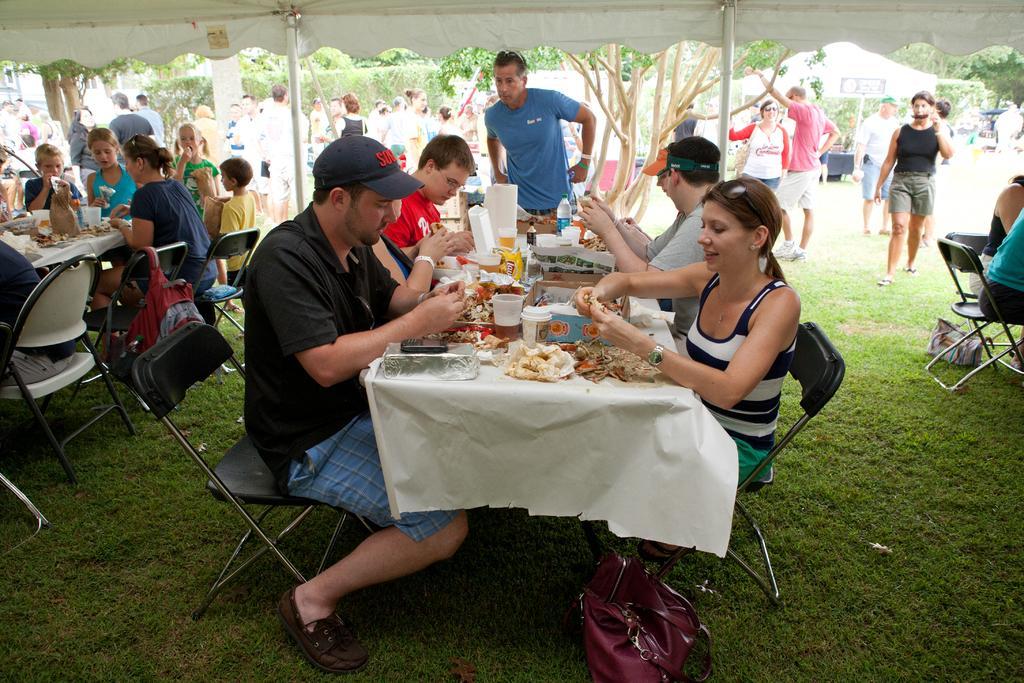In one or two sentences, can you explain what this image depicts? We can see all the persons sitting on chairs in front of a table and on the table we can see glasses, cups, mobile phones and we can see bag on a chair. And here we can see bag on a fresh grass. On the background we can see trees and few persons standing and talking to each other and walking. This is a tent in white colour. These are poles. 